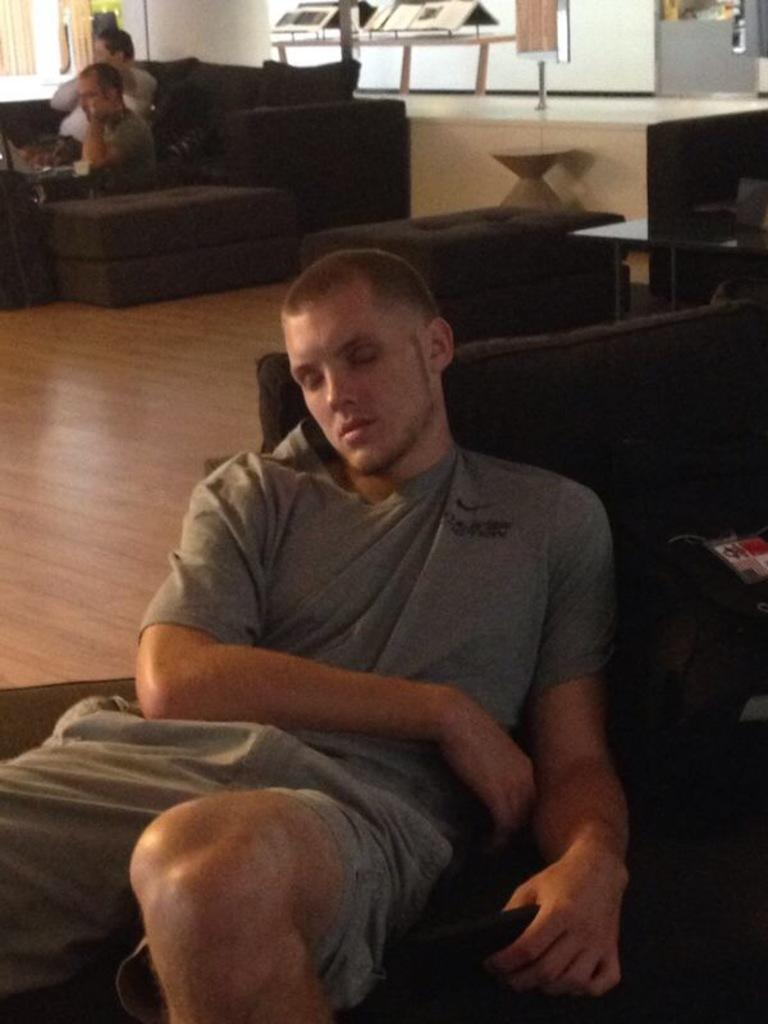What is the man in the image doing? The man is laying on a chair in the image. What can be seen in the background of the image? There are people sitting on a couch in the image. How many snakes are visible in the image? There are no snakes present in the image. What type of light is being used to illuminate the room in the image? The image does not provide information about the type of light being used in the room. 